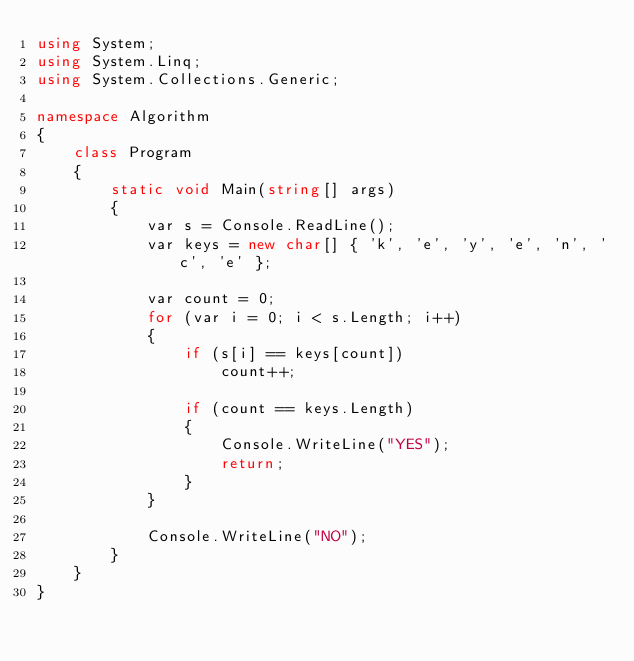<code> <loc_0><loc_0><loc_500><loc_500><_C#_>using System;
using System.Linq;
using System.Collections.Generic;

namespace Algorithm
{
    class Program
    {
        static void Main(string[] args)
        {
            var s = Console.ReadLine();
            var keys = new char[] { 'k', 'e', 'y', 'e', 'n', 'c', 'e' };

            var count = 0;
            for (var i = 0; i < s.Length; i++)
            {
                if (s[i] == keys[count])
                    count++;

                if (count == keys.Length)
                {
                    Console.WriteLine("YES");
                    return;
                }
            }

            Console.WriteLine("NO");
        }
    }
}</code> 